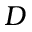Convert formula to latex. <formula><loc_0><loc_0><loc_500><loc_500>D</formula> 